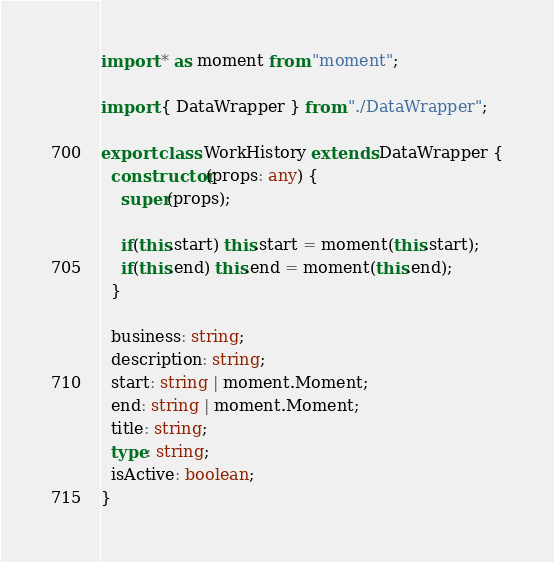Convert code to text. <code><loc_0><loc_0><loc_500><loc_500><_TypeScript_>import * as moment from "moment";

import { DataWrapper } from "./DataWrapper";

export class WorkHistory extends DataWrapper {
  constructor(props: any) {
    super(props);

    if(this.start) this.start = moment(this.start);
    if(this.end) this.end = moment(this.end);
  }

  business: string;
  description: string;
  start: string | moment.Moment;
  end: string | moment.Moment;
  title: string;
  type: string;
  isActive: boolean;
}
</code> 